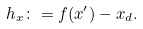Convert formula to latex. <formula><loc_0><loc_0><loc_500><loc_500>h _ { x } \colon = f ( x ^ { \prime } ) - x _ { d } .</formula> 